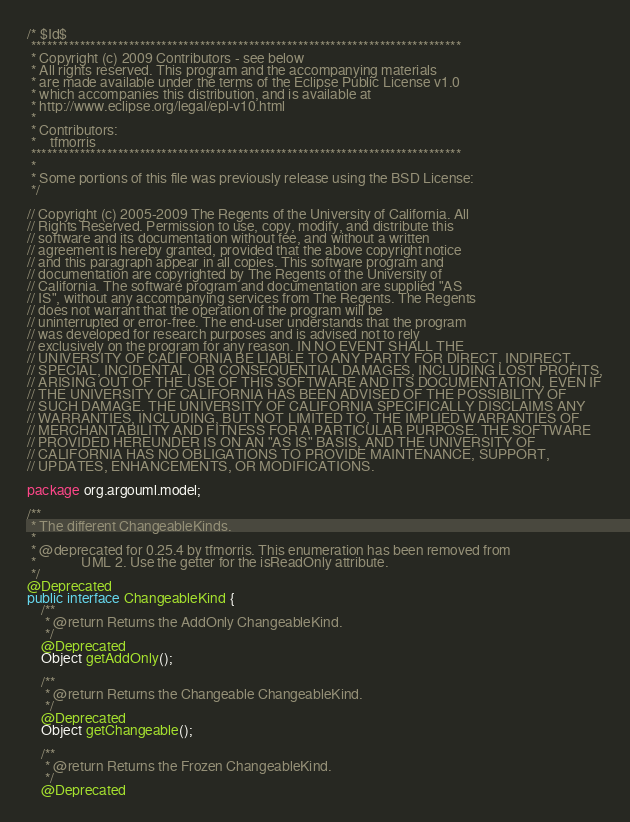Convert code to text. <code><loc_0><loc_0><loc_500><loc_500><_Java_>/* $Id$
 *******************************************************************************
 * Copyright (c) 2009 Contributors - see below
 * All rights reserved. This program and the accompanying materials
 * are made available under the terms of the Eclipse Public License v1.0
 * which accompanies this distribution, and is available at
 * http://www.eclipse.org/legal/epl-v10.html
 *
 * Contributors:
 *    tfmorris
 *******************************************************************************
 *
 * Some portions of this file was previously release using the BSD License:
 */

// Copyright (c) 2005-2009 The Regents of the University of California. All
// Rights Reserved. Permission to use, copy, modify, and distribute this
// software and its documentation without fee, and without a written
// agreement is hereby granted, provided that the above copyright notice
// and this paragraph appear in all copies. This software program and
// documentation are copyrighted by The Regents of the University of
// California. The software program and documentation are supplied "AS
// IS", without any accompanying services from The Regents. The Regents
// does not warrant that the operation of the program will be
// uninterrupted or error-free. The end-user understands that the program
// was developed for research purposes and is advised not to rely
// exclusively on the program for any reason. IN NO EVENT SHALL THE
// UNIVERSITY OF CALIFORNIA BE LIABLE TO ANY PARTY FOR DIRECT, INDIRECT,
// SPECIAL, INCIDENTAL, OR CONSEQUENTIAL DAMAGES, INCLUDING LOST PROFITS,
// ARISING OUT OF THE USE OF THIS SOFTWARE AND ITS DOCUMENTATION, EVEN IF
// THE UNIVERSITY OF CALIFORNIA HAS BEEN ADVISED OF THE POSSIBILITY OF
// SUCH DAMAGE. THE UNIVERSITY OF CALIFORNIA SPECIFICALLY DISCLAIMS ANY
// WARRANTIES, INCLUDING, BUT NOT LIMITED TO, THE IMPLIED WARRANTIES OF
// MERCHANTABILITY AND FITNESS FOR A PARTICULAR PURPOSE. THE SOFTWARE
// PROVIDED HEREUNDER IS ON AN "AS IS" BASIS, AND THE UNIVERSITY OF
// CALIFORNIA HAS NO OBLIGATIONS TO PROVIDE MAINTENANCE, SUPPORT,
// UPDATES, ENHANCEMENTS, OR MODIFICATIONS.

package org.argouml.model;

/**
 * The different ChangeableKinds.
 * 
 * @deprecated for 0.25.4 by tfmorris. This enumeration has been removed from
 *             UML 2. Use the getter for the isReadOnly attribute.
 */
@Deprecated
public interface ChangeableKind {
    /**
     * @return Returns the AddOnly ChangeableKind.
     */
    @Deprecated
    Object getAddOnly();

    /**
     * @return Returns the Changeable ChangeableKind.
     */
    @Deprecated
    Object getChangeable();

    /**
     * @return Returns the Frozen ChangeableKind.
     */
    @Deprecated</code> 